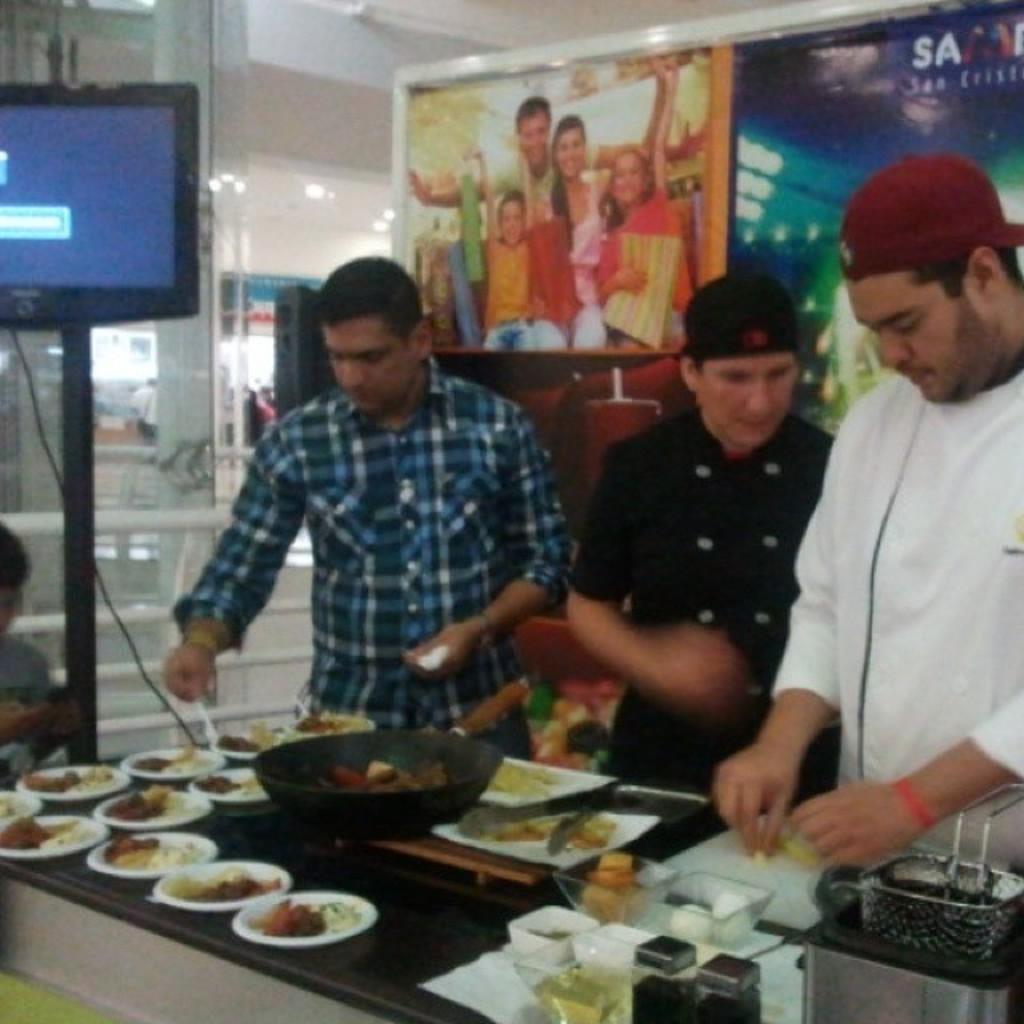Could you give a brief overview of what you see in this image? In this image I can see number of plates, few bowls, and utensils and different types of food. I can also see few other stuffs on the bottom side. In the centre of the image I can see three persons are standing and I can see two of them are wearing caps. In the background I can see two boards, a television and on these words I can see something is written. On the top side of the image I can also see a picture of few people on the board. On the left side of the image I can see one more person and I can also see this image is little bit blurry. 